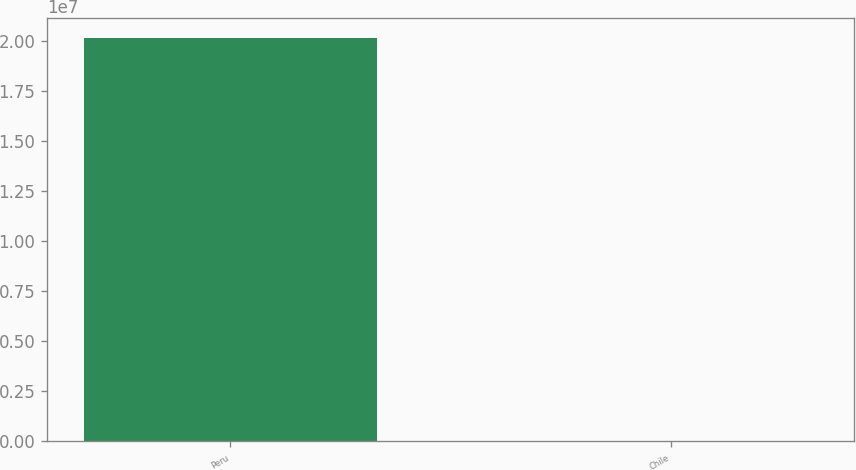Convert chart to OTSL. <chart><loc_0><loc_0><loc_500><loc_500><bar_chart><fcel>Peru<fcel>Chile<nl><fcel>2.0142e+07<fcel>2018<nl></chart> 